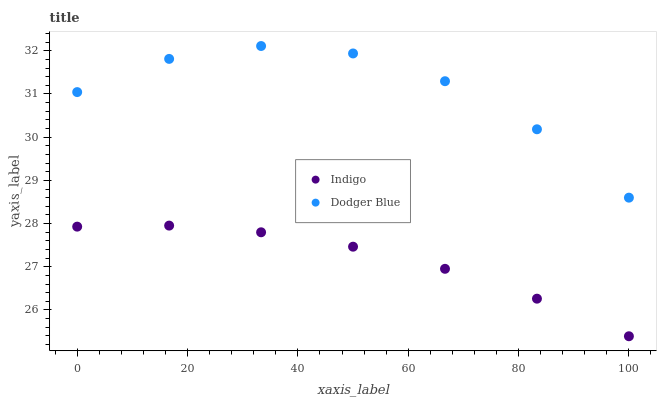Does Indigo have the minimum area under the curve?
Answer yes or no. Yes. Does Dodger Blue have the maximum area under the curve?
Answer yes or no. Yes. Does Indigo have the maximum area under the curve?
Answer yes or no. No. Is Indigo the smoothest?
Answer yes or no. Yes. Is Dodger Blue the roughest?
Answer yes or no. Yes. Is Indigo the roughest?
Answer yes or no. No. Does Indigo have the lowest value?
Answer yes or no. Yes. Does Dodger Blue have the highest value?
Answer yes or no. Yes. Does Indigo have the highest value?
Answer yes or no. No. Is Indigo less than Dodger Blue?
Answer yes or no. Yes. Is Dodger Blue greater than Indigo?
Answer yes or no. Yes. Does Indigo intersect Dodger Blue?
Answer yes or no. No. 